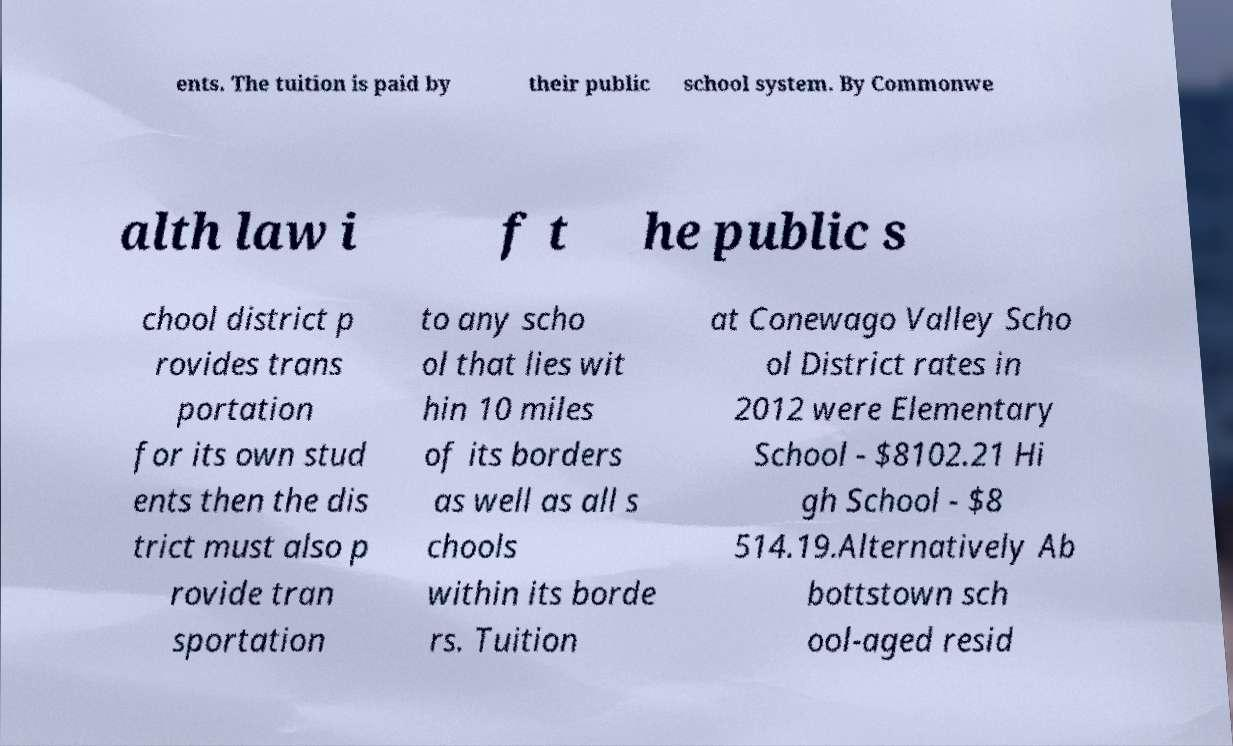Please identify and transcribe the text found in this image. ents. The tuition is paid by their public school system. By Commonwe alth law i f t he public s chool district p rovides trans portation for its own stud ents then the dis trict must also p rovide tran sportation to any scho ol that lies wit hin 10 miles of its borders as well as all s chools within its borde rs. Tuition at Conewago Valley Scho ol District rates in 2012 were Elementary School - $8102.21 Hi gh School - $8 514.19.Alternatively Ab bottstown sch ool-aged resid 